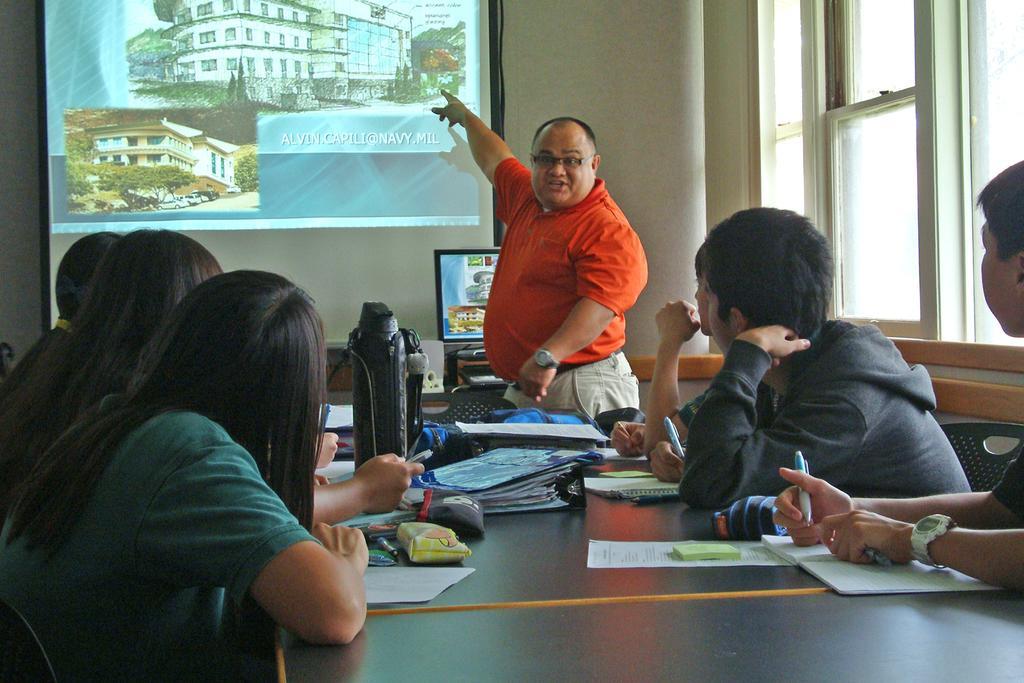In one or two sentences, can you explain what this image depicts? In this image we can see a man standing beside a table containing some books, pens, papers, pouches, bags and some objects placed on it. We can also see a group of people sitting on the chairs. In that some are holding the pens. We can also see the monitor on a table, a display screen, window and a wall. 